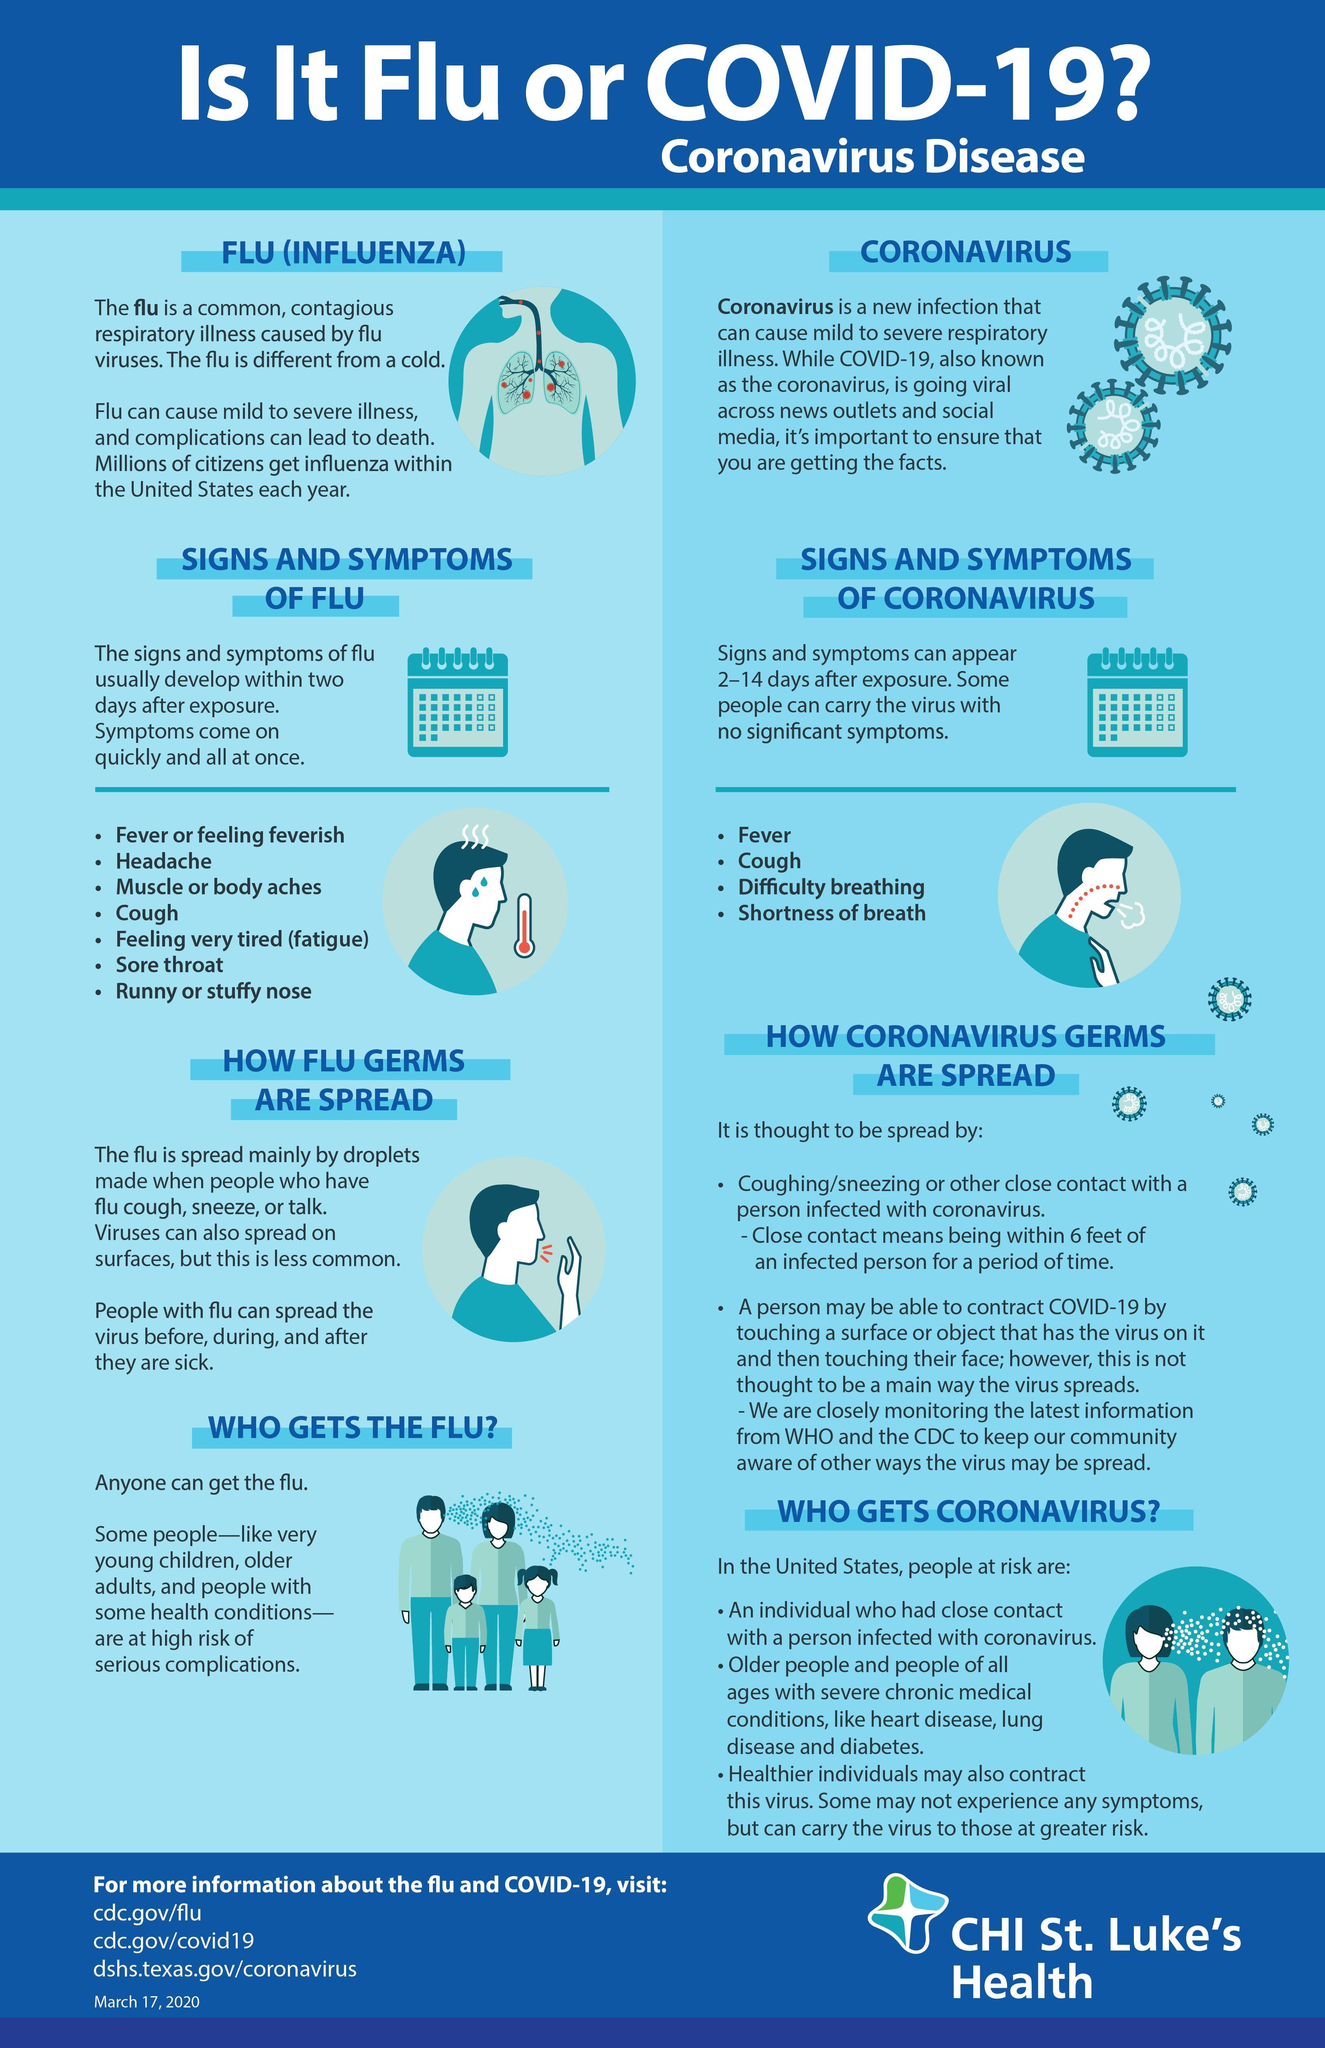Which symptoms are common to flu and corona virus?
Answer the question with a short phrase. Fever, Cough 